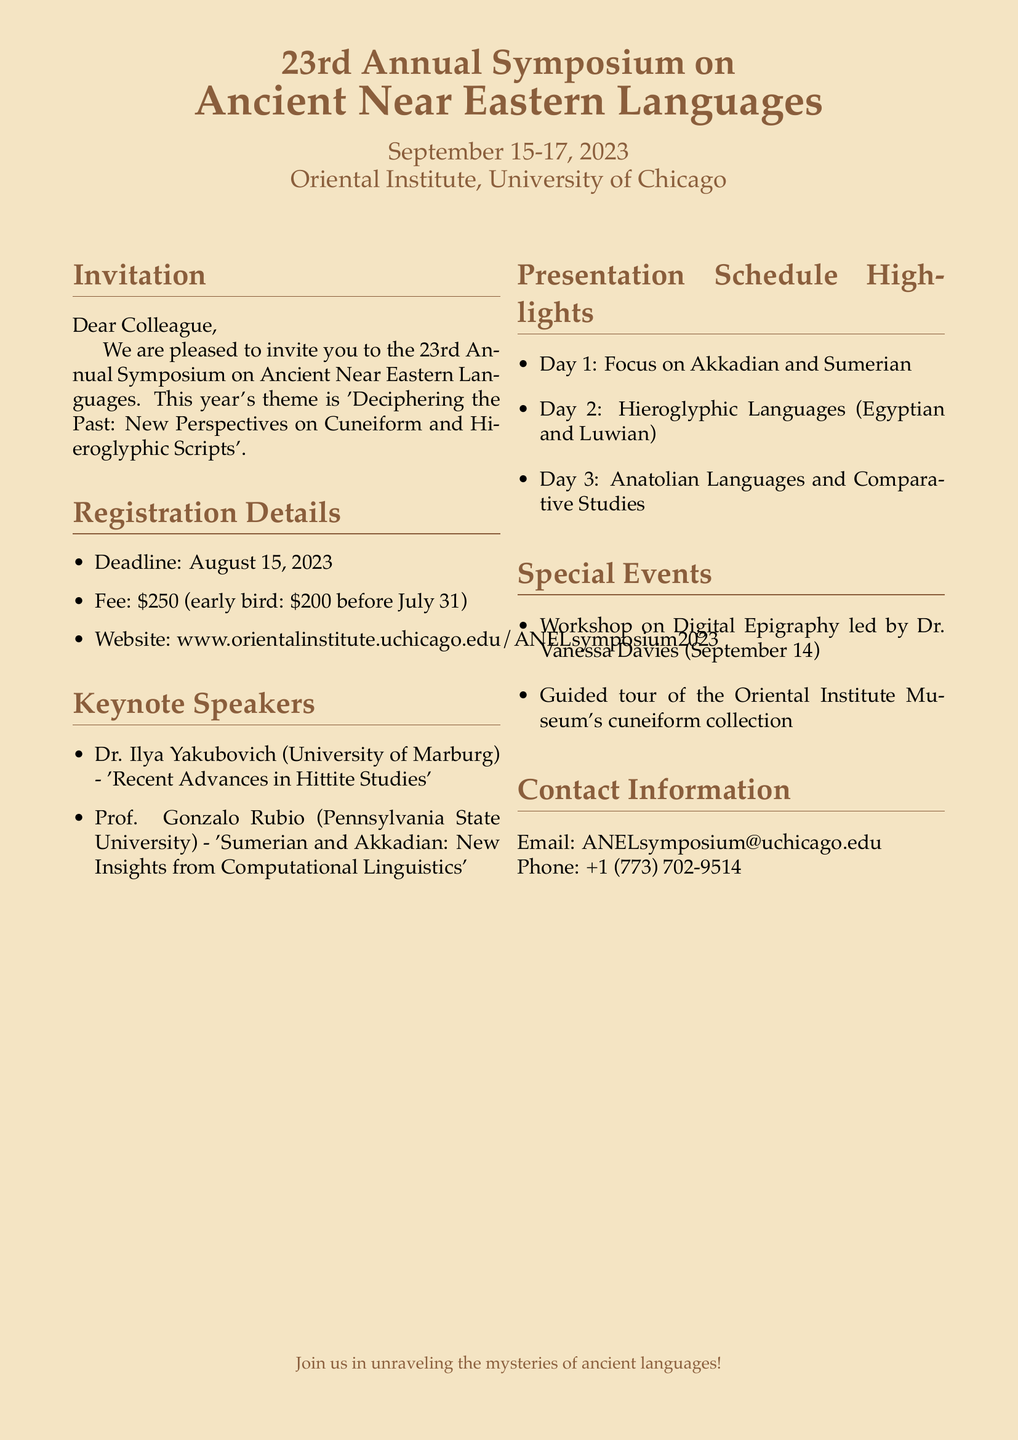What are the dates of the symposium? The symposium is scheduled for September 15-17, 2023.
Answer: September 15-17, 2023 What is the early bird registration fee? The early bird registration fee is lower than the regular fee and is noted as \$200 before July 31.
Answer: \$200 Who is a keynote speaker? Keynote speakers have been specifically listed, and one example is provided.
Answer: Dr. Ilya Yakubovich What is the theme of this year's symposium? The document specifies the theme of the symposium is 'Deciphering the Past: New Perspectives on Cuneiform and Hieroglyphic Scripts'.
Answer: Deciphering the Past: New Perspectives on Cuneiform and Hieroglyphic Scripts On which topic is Day 3 focused? The document categorizes the presentation schedule by days. Day 3 is associated with a specific focus area.
Answer: Anatolian Languages and Comparative Studies What special event is occurring on September 14? A workshop is mentioned in the document with a specific date prior to the symposium.
Answer: Workshop on Digital Epigraphy What is the website for registration? The document provides a specific URL for the registration details.
Answer: www.orientalinstitute.uchicago.edu/ANELsymposium2023 What is the contact phone number for the symposium? The document lists contact information including a phone number.
Answer: +1 (773) 702-9514 